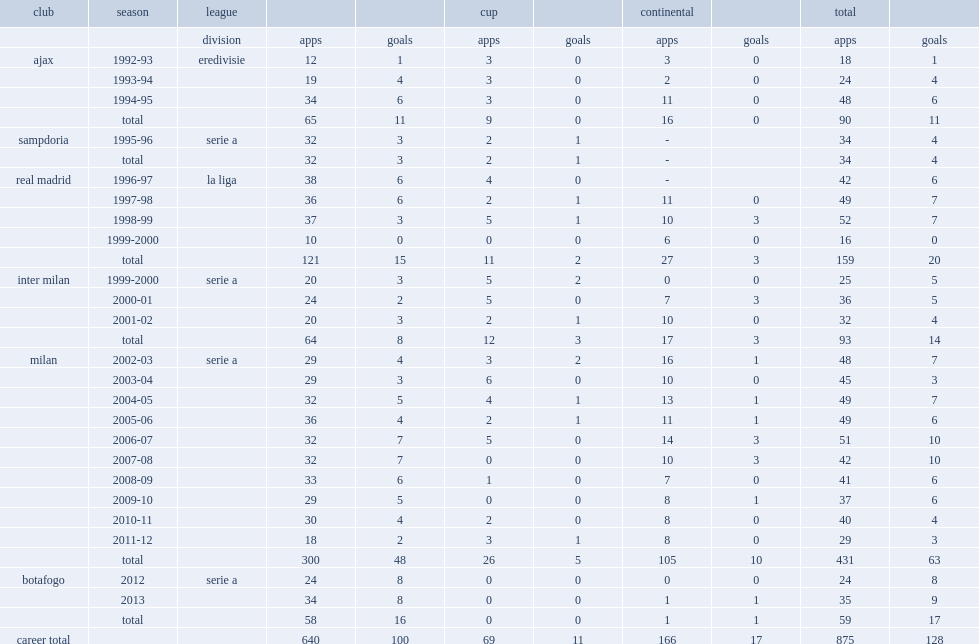In 2003-04 season, which league did seedorf play for milan? Serie a. 